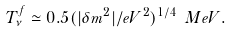<formula> <loc_0><loc_0><loc_500><loc_500>T _ { \nu } ^ { f } \simeq 0 . 5 ( | \delta m ^ { 2 } | / e V ^ { 2 } ) ^ { 1 / 4 } \ M e V .</formula> 